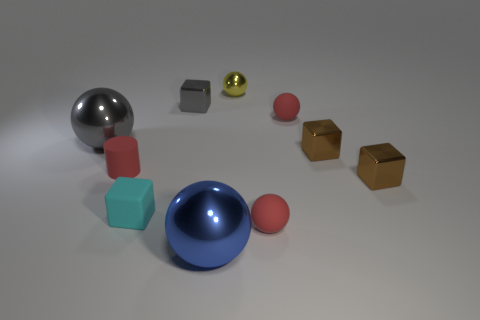Subtract all blue spheres. How many spheres are left? 4 Subtract all gray balls. How many balls are left? 4 Subtract 1 spheres. How many spheres are left? 4 Subtract all brown spheres. Subtract all brown blocks. How many spheres are left? 5 Subtract all cubes. How many objects are left? 6 Add 5 tiny yellow spheres. How many tiny yellow spheres are left? 6 Add 3 cyan rubber objects. How many cyan rubber objects exist? 4 Subtract 0 blue cylinders. How many objects are left? 10 Subtract all metallic balls. Subtract all red rubber balls. How many objects are left? 5 